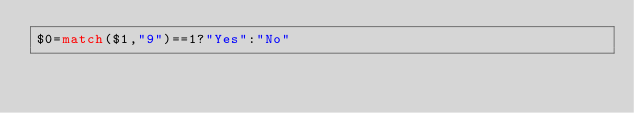<code> <loc_0><loc_0><loc_500><loc_500><_Awk_>$0=match($1,"9")==1?"Yes":"No"</code> 